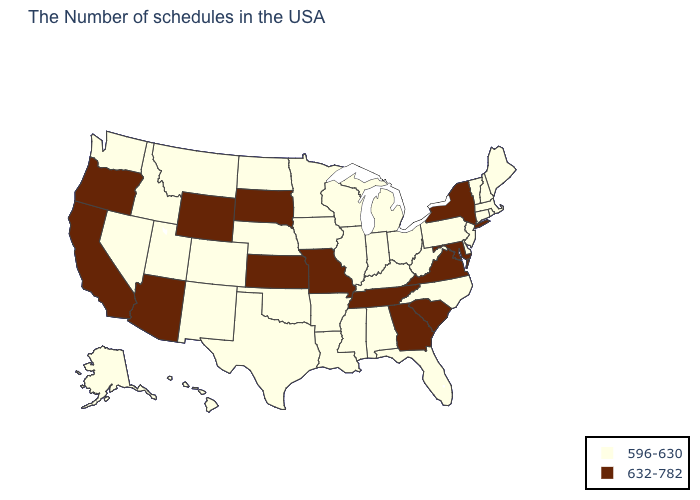Does New Mexico have a higher value than South Dakota?
Quick response, please. No. What is the value of Massachusetts?
Concise answer only. 596-630. What is the value of Delaware?
Answer briefly. 596-630. Name the states that have a value in the range 632-782?
Be succinct. New York, Maryland, Virginia, South Carolina, Georgia, Tennessee, Missouri, Kansas, South Dakota, Wyoming, Arizona, California, Oregon. How many symbols are there in the legend?
Keep it brief. 2. What is the lowest value in states that border West Virginia?
Short answer required. 596-630. Does the first symbol in the legend represent the smallest category?
Be succinct. Yes. Name the states that have a value in the range 596-630?
Write a very short answer. Maine, Massachusetts, Rhode Island, New Hampshire, Vermont, Connecticut, New Jersey, Delaware, Pennsylvania, North Carolina, West Virginia, Ohio, Florida, Michigan, Kentucky, Indiana, Alabama, Wisconsin, Illinois, Mississippi, Louisiana, Arkansas, Minnesota, Iowa, Nebraska, Oklahoma, Texas, North Dakota, Colorado, New Mexico, Utah, Montana, Idaho, Nevada, Washington, Alaska, Hawaii. What is the lowest value in the West?
Write a very short answer. 596-630. Does West Virginia have a higher value than South Carolina?
Answer briefly. No. Does Kentucky have the lowest value in the USA?
Keep it brief. Yes. Among the states that border Connecticut , which have the lowest value?
Write a very short answer. Massachusetts, Rhode Island. How many symbols are there in the legend?
Quick response, please. 2. What is the value of Alaska?
Answer briefly. 596-630. 